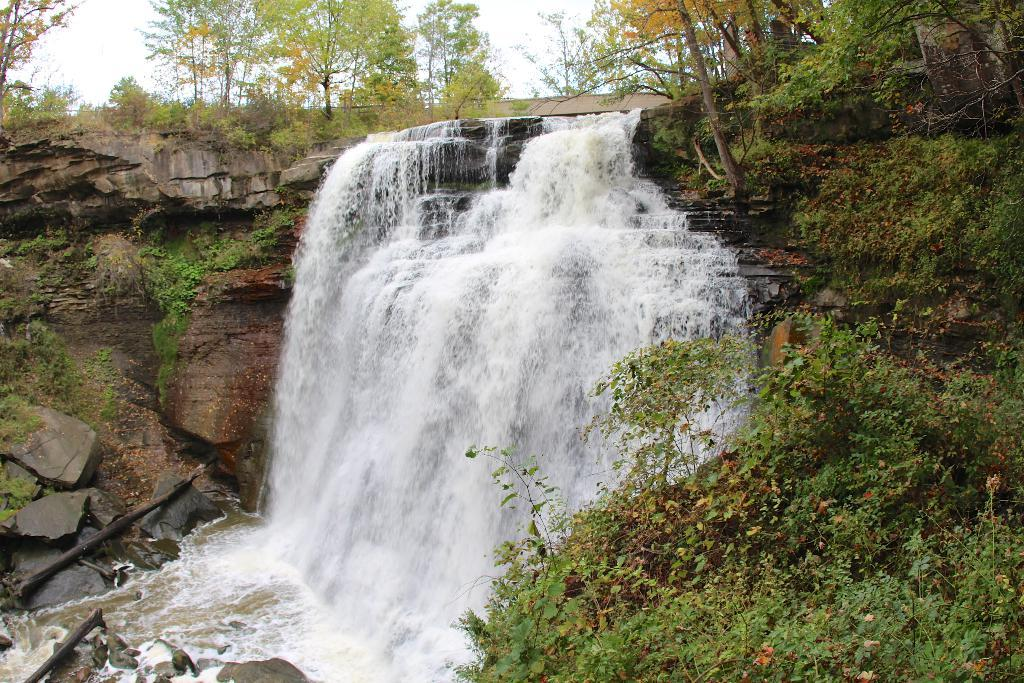What natural feature is the main subject of the image? There is a waterfall in the image. What type of vegetation can be seen in the image? Grass, plants, and trees are visible in the image. What other natural elements are present in the image? Rocks are present in the image. What can be seen in the sky in the image? The sky is visible in the image. What type of cake is being served for dinner in the image? There is no cake or dinner present in the image; it features a waterfall and natural surroundings. Who is the porter in the image? There is no porter present in the image. 